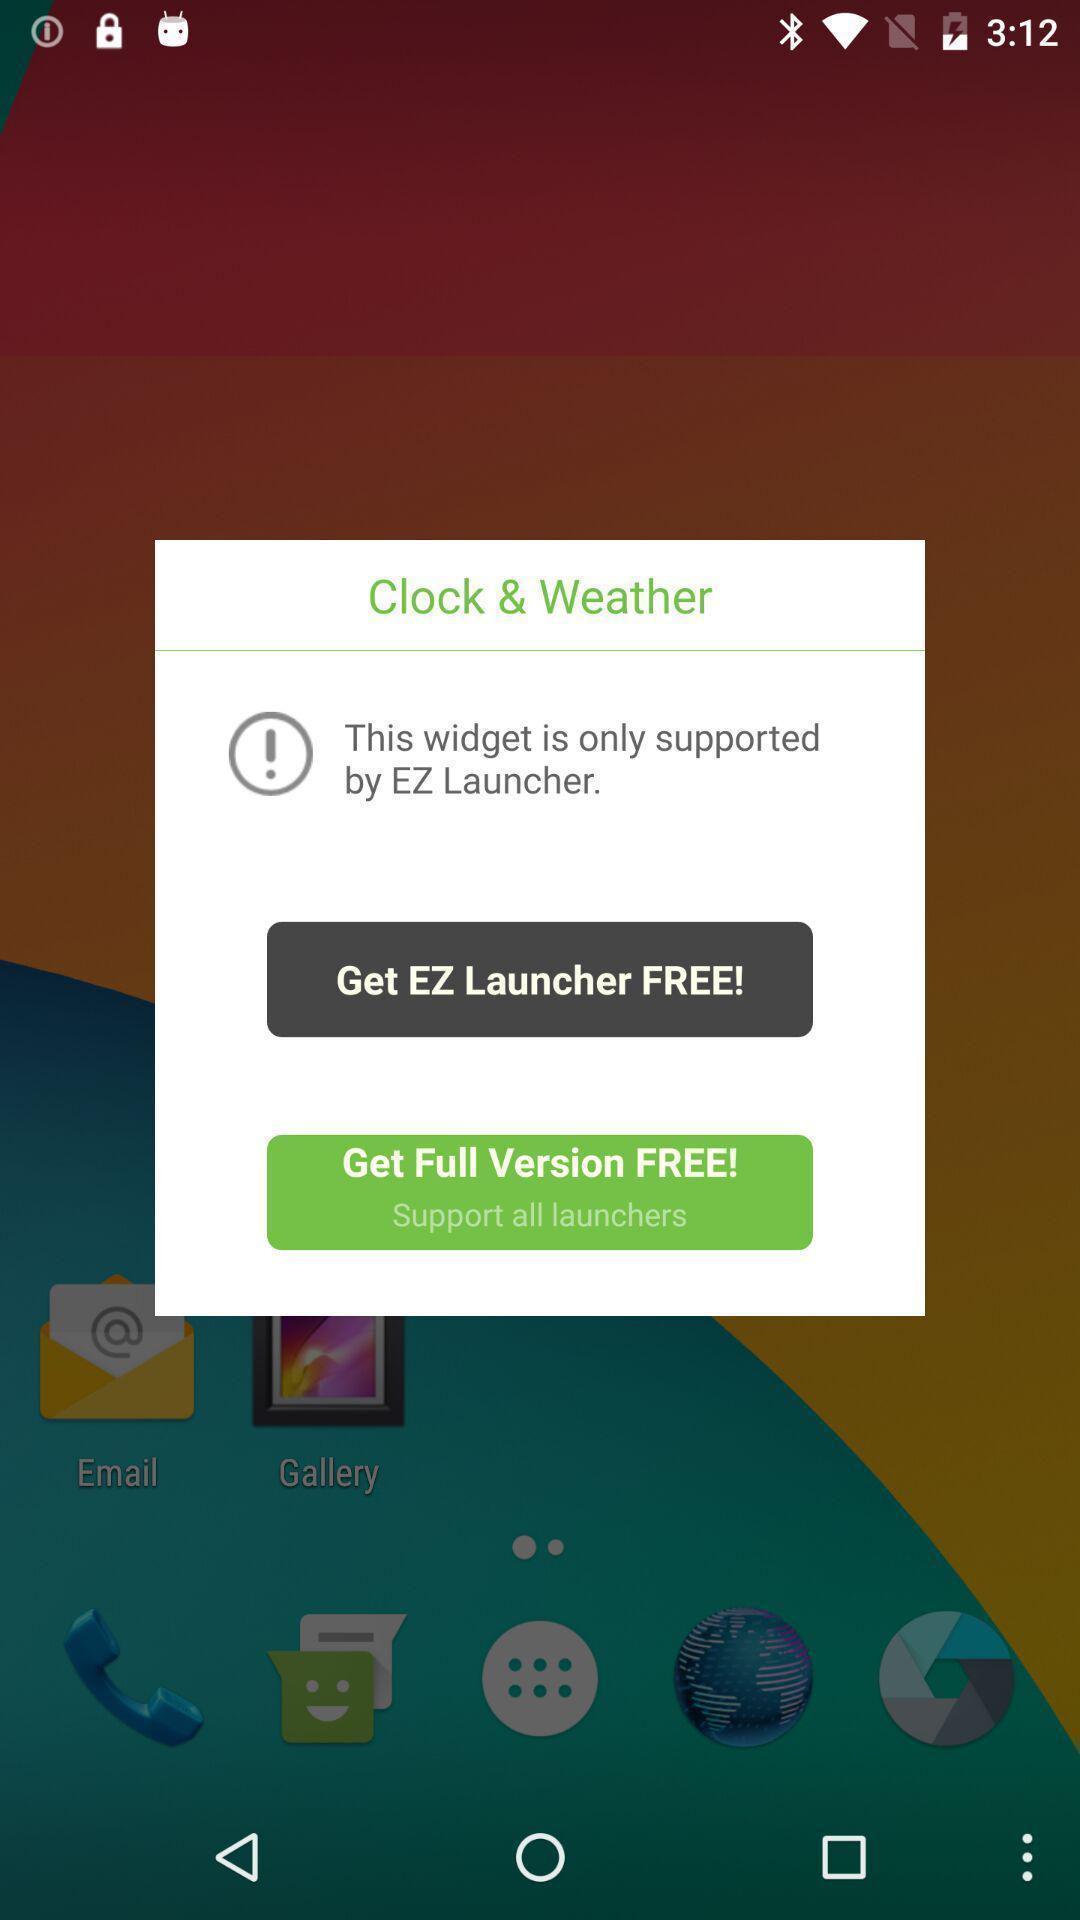Explain what's happening in this screen capture. Pop-up shows launcher details. 